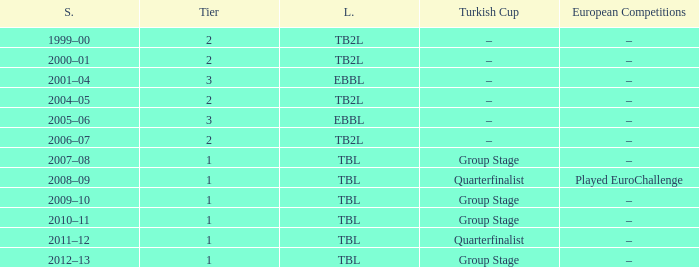Season of 2012–13 is what league? TBL. 